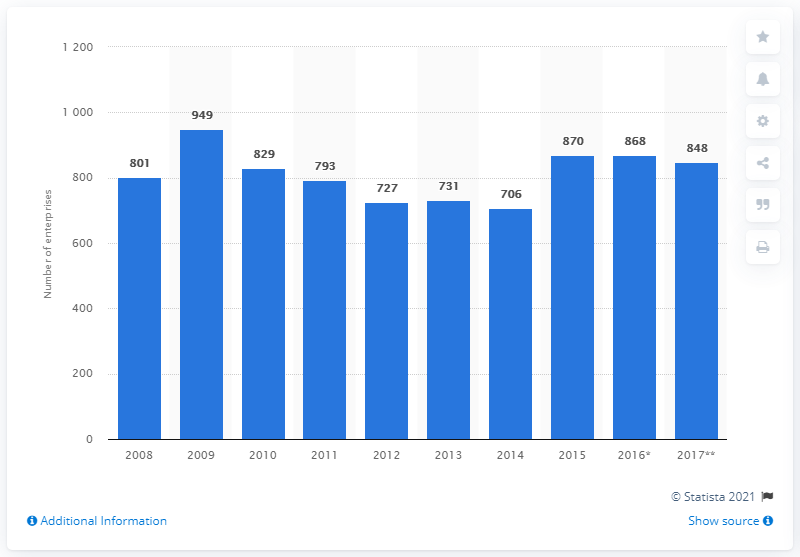Indicate a few pertinent items in this graphic. There were a total of 868 enterprises manufacturing computers and peripheral equipment in the UK in 2016. 